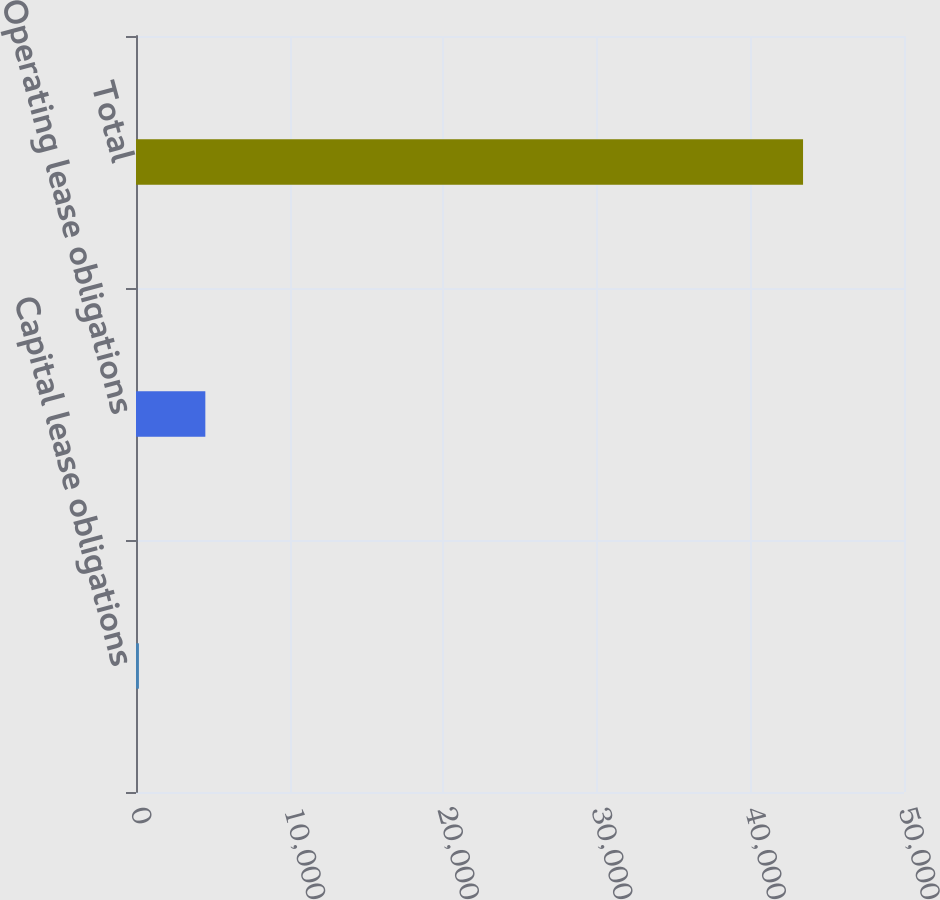Convert chart. <chart><loc_0><loc_0><loc_500><loc_500><bar_chart><fcel>Capital lease obligations<fcel>Operating lease obligations<fcel>Total<nl><fcel>190<fcel>4513.8<fcel>43428<nl></chart> 